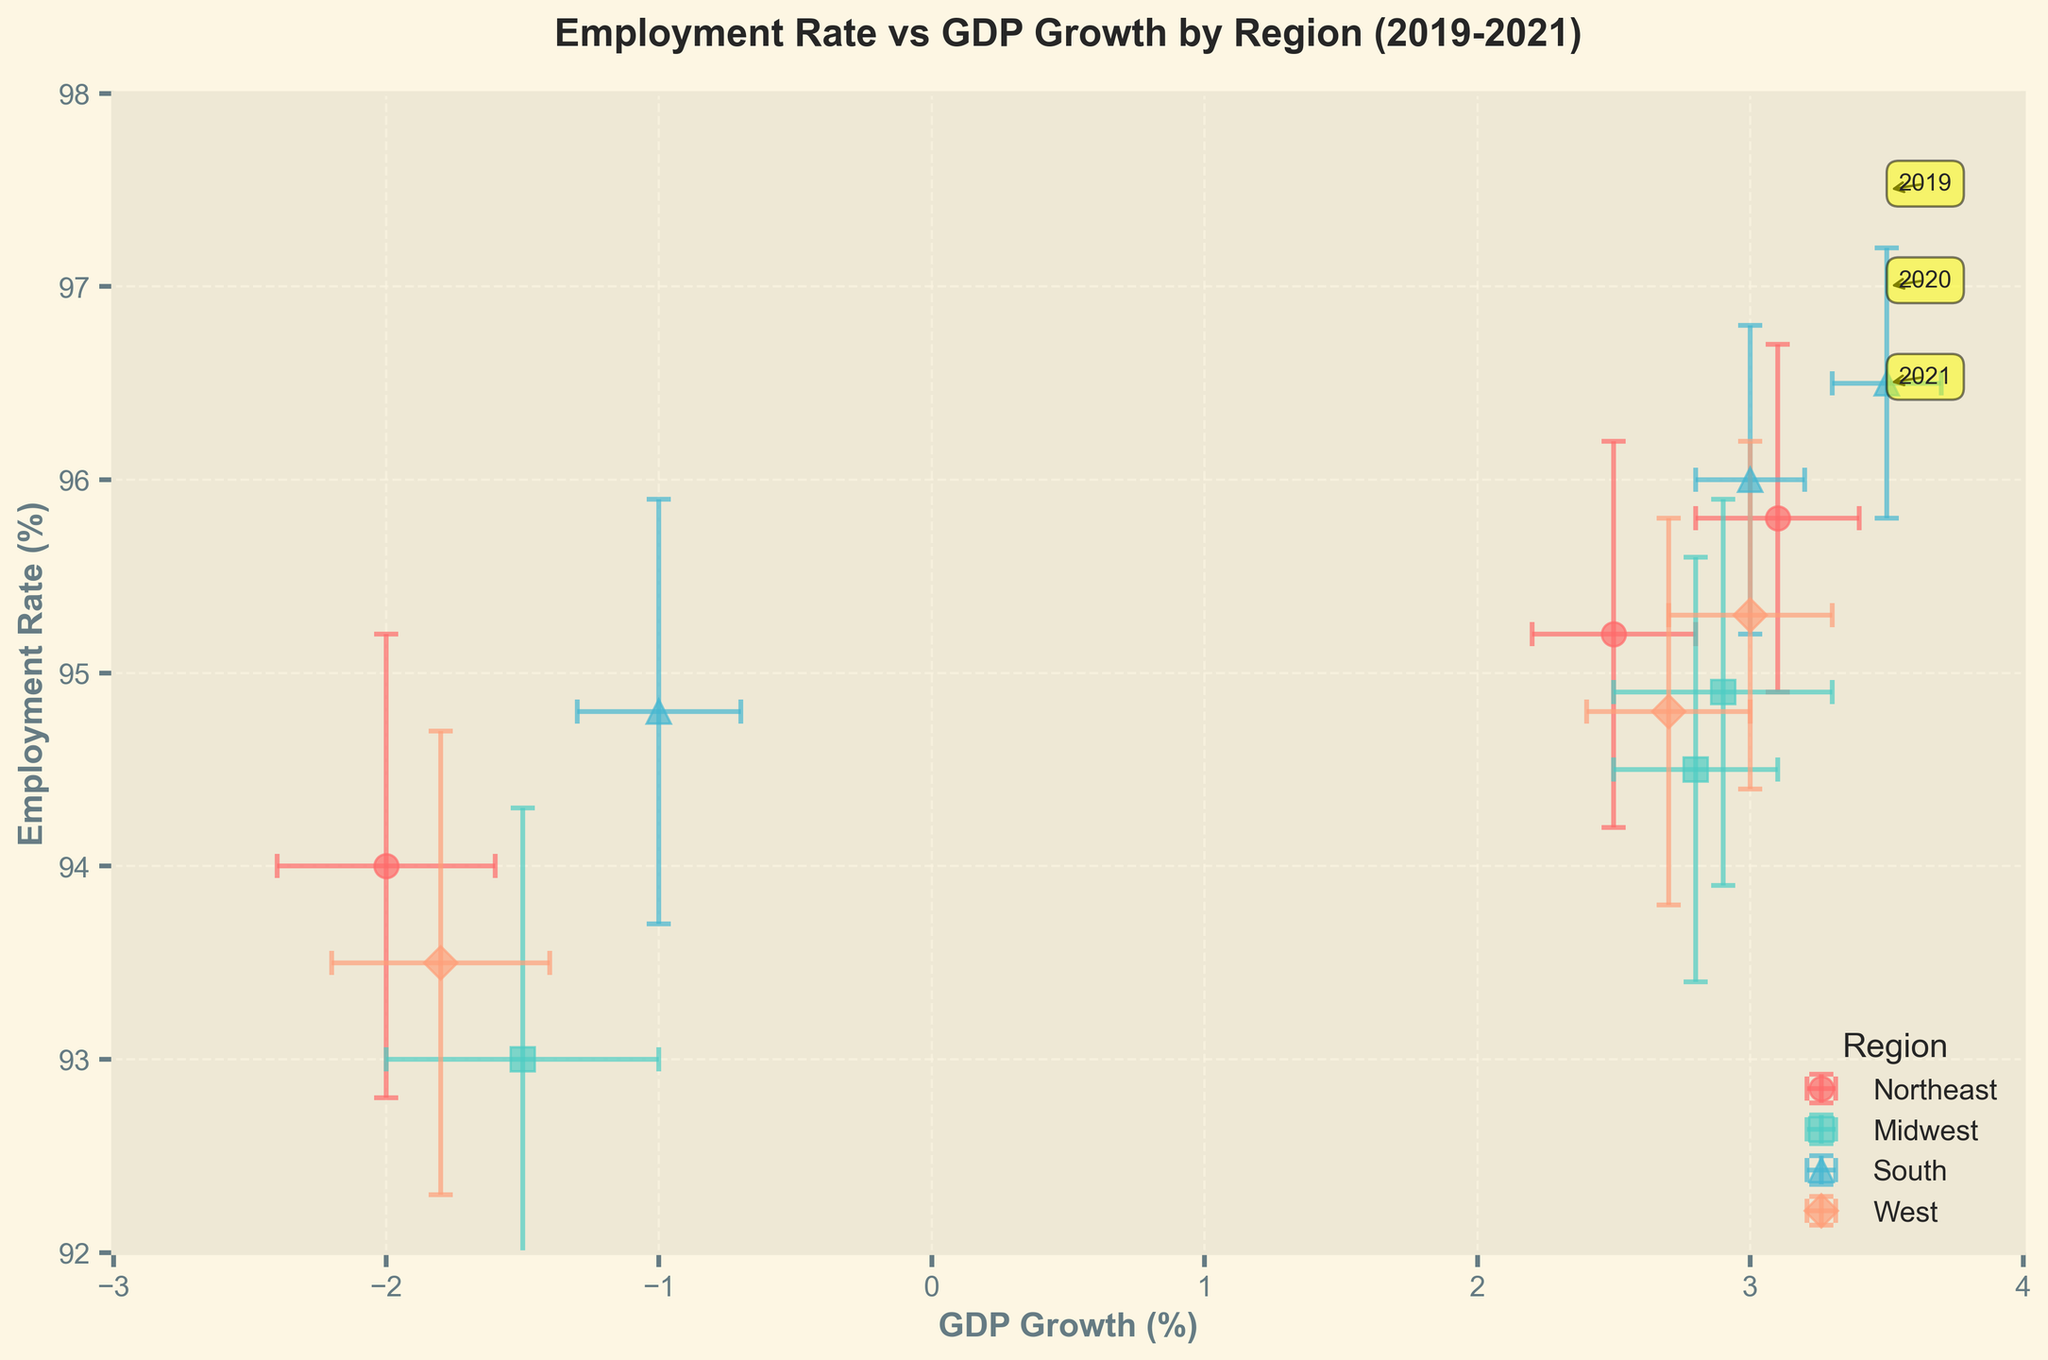What regions are represented in the scatter plot? The scatter plot uses different colors and markers to denote various regions. The legend indicates that the regions are Northeast, Midwest, South, and West.
Answer: Northeast, Midwest, South, West What is the main title of the scatter plot? The title of the scatter plot is shown at the top of the figure. It reads: "Employment Rate vs GDP Growth by Region (2019-2021)."
Answer: Employment Rate vs GDP Growth by Region (2019-2021) Which region shows the highest Employment Rate in 2021? By looking at the y-axis for Employment Rate and noting the labeled points, the South region shows the highest Employment Rate in 2021 with a rate of 96.5%.
Answer: South Which year shows a negative GDP Growth in all regions? All data points for 2020 show negative values on the x-axis, indicating negative GDP Growth for all regions in that year.
Answer: 2020 What is the average Employment Rate for the West region across the years 2019, 2020, and 2021? The Employment Rates for the West region are 94.8%, 93.5%, and 95.3% for the years 2019, 2020, and 2021, respectively. Calculating the average: (94.8 + 93.5 + 95.3) / 3 = 94.53%.
Answer: 94.53% Which region experienced the largest decline in Employment Rate from 2019 to 2020? The Employment Rates for 2019 and 2020 in each region are: Northeast (95.2 to 94.0), Midwest (94.5 to 93.0), South (96.0 to 94.8), and West (94.8 to 93.5). The largest decline is seen in the Midwest from 94.5 to 93.0, which is a decline of 1.5%.
Answer: Midwest How does the Employment Rate of the Northeast in 2020 compare to its Employment Rate in 2021? The Employment Rate of the Northeast in 2020 is 94.0% and in 2021 it is 95.8%. It increased by 1.8% from 2020 to 2021.
Answer: Increased by 1.8% What is the relationship between GDP Growth and Employment Rate for the South region in 2021? On the scatter plot, the South region in 2021 has a GDP Growth of 3.5% and an Employment Rate of 96.5%. Both metrics are high compared to other regions and years.
Answer: Both high Does any region have an Employment Rate error greater than 1.0 in 2021? By observing the error bars for each region in 2021 and their corresponding labels, no region in 2021 has an Employment Rate error exceeding 1.0 as all error bars are equal to or less than 1.0.
Answer: No Which region had consistent GDP Growth and Employment Rates with low variability as indicated by smaller error bars? By comparing the size of the error bars in the scatter plot, the South region consistently has among the smallest error bars for both GDP Growth and Employment Rates across all years, indicating low variability.
Answer: South 